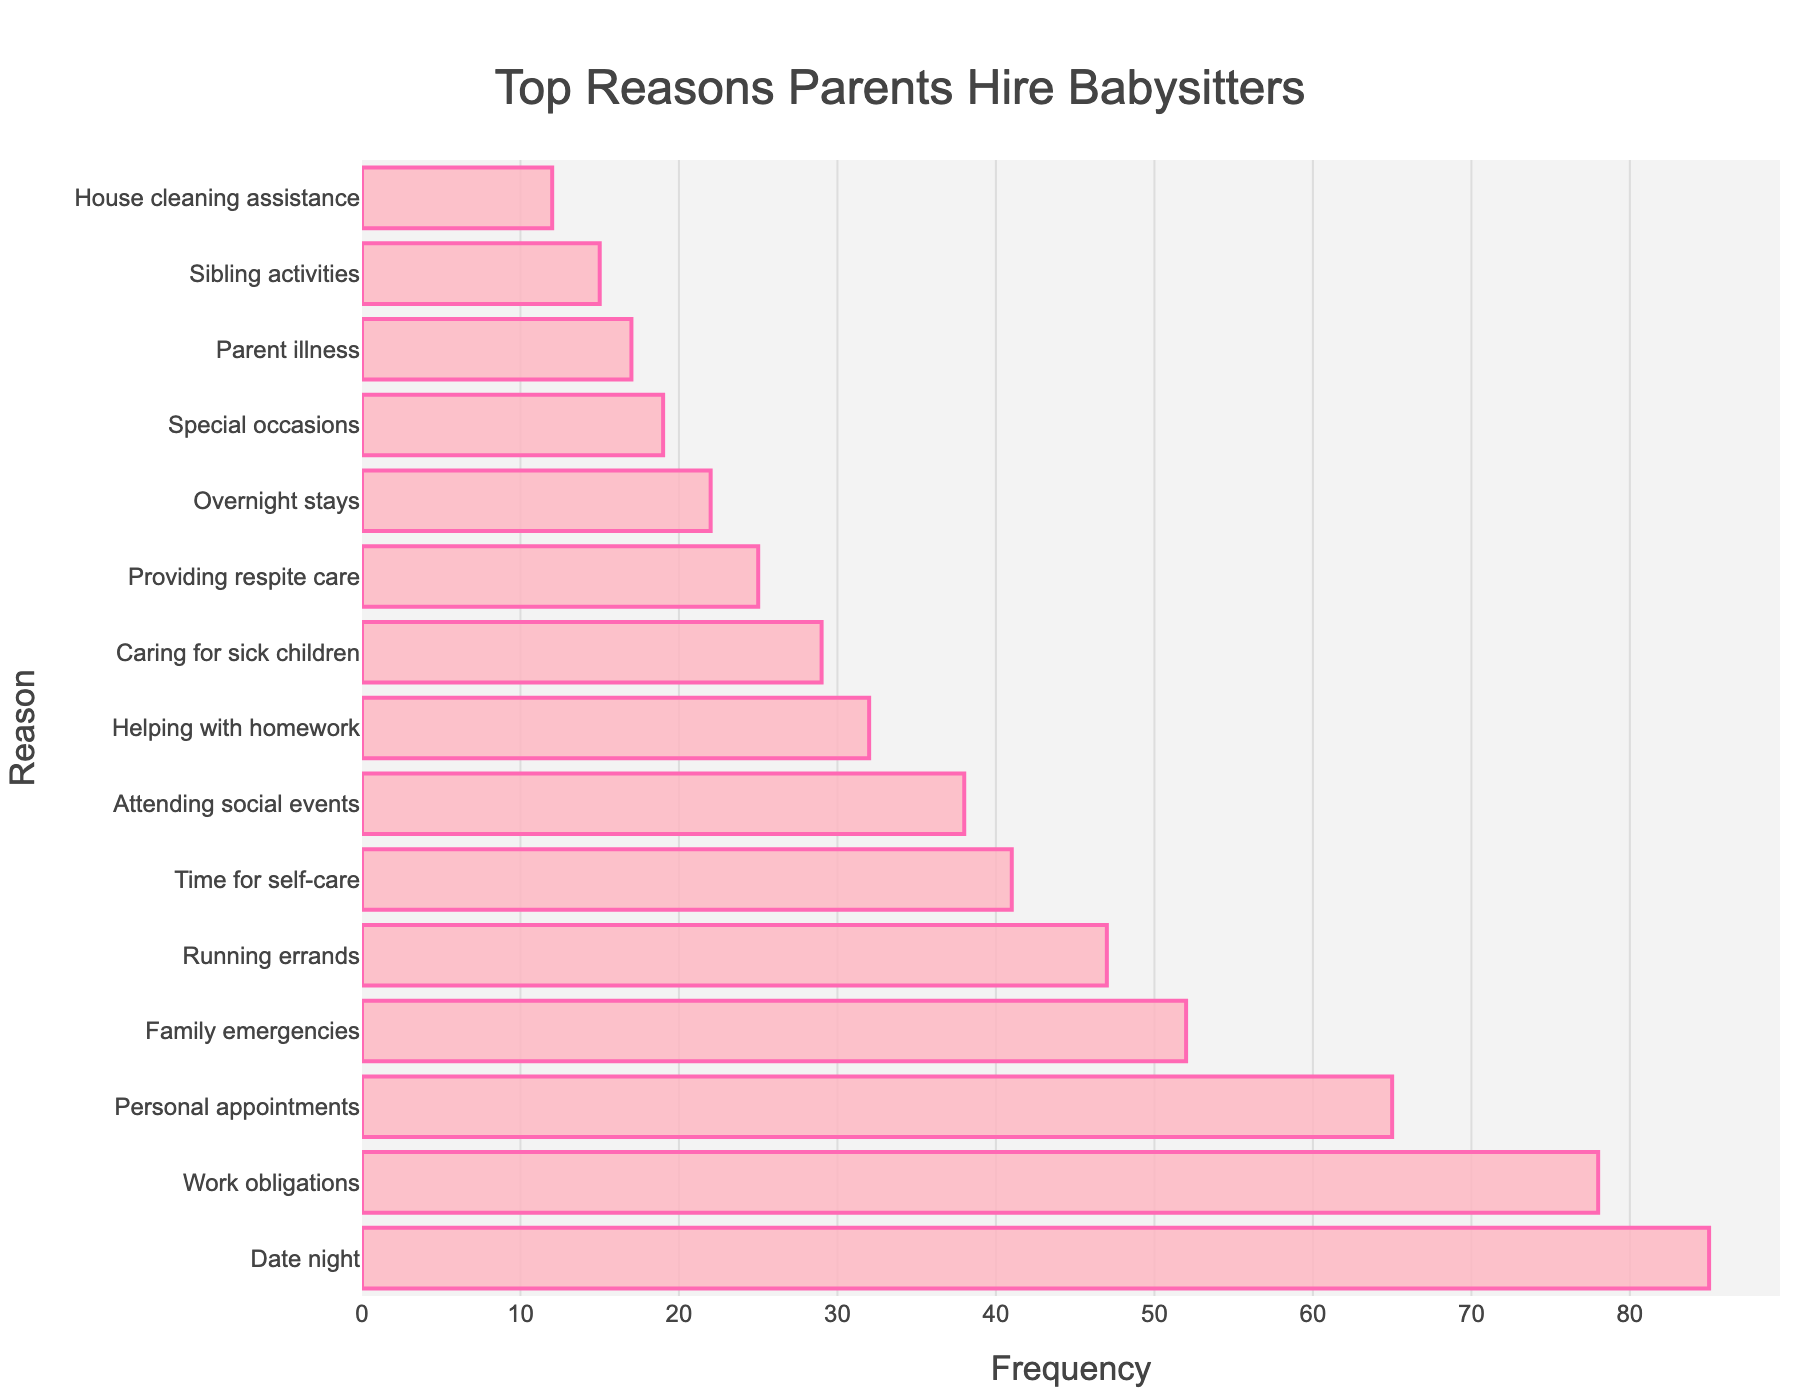What is the most common reason parents hire babysitters? The most common reason can be identified by the bar with the greatest length. The bar labeled "Date night" has the highest frequency, which is 85.
Answer: Date night How much more frequent is "Date night" compared to "Work obligations"? Calculate the difference in frequency between "Date night" and "Work obligations", which are 85 and 78 respectively. The difference is 85 - 78.
Answer: 7 What is the combined frequency for "Running errands" and "Time for self-care"? Add the frequencies of "Running errands" and "Time for self-care". The values are 47 and 41 respectively. The sum is 47 + 41.
Answer: 88 Among the reasons listed, which one is the least common and what is its frequency? Identify the shortest bar on the chart representing the lowest frequency. The bar labeled "House cleaning assistance" has the lowest frequency, which is 12.
Answer: House cleaning assistance, 12 Which reason has a higher frequency: "Family emergencies" or "Personal appointments"? By how much? Compare the lengths of the bars for "Family emergencies" and "Personal appointments". "Personal appointments" has a frequency of 65, while "Family emergencies" has a frequency of 52. The difference is 65 - 52.
Answer: Personal appointments, 13 How many reasons have a frequency greater than 50? Count the number of bars whose lengths correspond to frequencies greater than 50. These reasons are "Date night", "Work obligations", "Personal appointments", and "Family emergencies". There are 4 such reasons.
Answer: 4 What percentage of the total frequency does "Attending social events" represent? First, sum all frequencies: 85 + 78 + 65 + 52 + 47 + 41 + 38 + 32 + 29 + 25 + 22 + 19 + 17 + 15 + 12 = 577. The percentage is then calculated by (38 / 577) * 100%.
Answer: 6.58% What are the two least common reasons for hiring babysitters and their combined frequency? Identify the two shortest bars. They are "House cleaning assistance" (12) and "Sibling activities" (15). Their combined frequency is 12 + 15.
Answer: House cleaning assistance and Sibling activities, 27 Is there a reason whose frequency is exactly halfway between "Helping with homework" and "Caring for sick children"? The frequencies for "Helping with homework" and "Caring for sick children" are 32 and 29, respectively. The average of these values is (32 + 29) / 2 = 30.5. Since the data must be an integer frequency, no reason fits exactly halfway.
Answer: No 